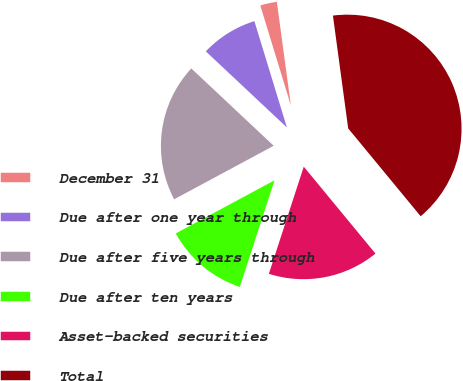Convert chart. <chart><loc_0><loc_0><loc_500><loc_500><pie_chart><fcel>December 31<fcel>Due after one year through<fcel>Due after five years through<fcel>Due after ten years<fcel>Asset-backed securities<fcel>Total<nl><fcel>2.58%<fcel>8.28%<fcel>19.85%<fcel>12.13%<fcel>15.99%<fcel>41.16%<nl></chart> 